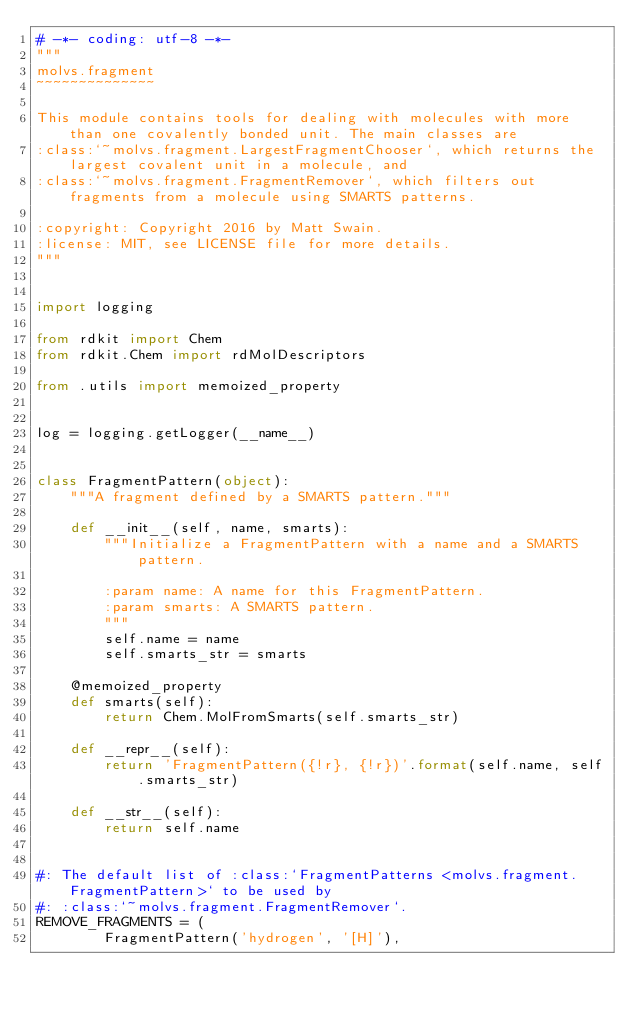Convert code to text. <code><loc_0><loc_0><loc_500><loc_500><_Python_># -*- coding: utf-8 -*-
"""
molvs.fragment
~~~~~~~~~~~~~~

This module contains tools for dealing with molecules with more than one covalently bonded unit. The main classes are
:class:`~molvs.fragment.LargestFragmentChooser`, which returns the largest covalent unit in a molecule, and
:class:`~molvs.fragment.FragmentRemover`, which filters out fragments from a molecule using SMARTS patterns.

:copyright: Copyright 2016 by Matt Swain.
:license: MIT, see LICENSE file for more details.
"""


import logging

from rdkit import Chem
from rdkit.Chem import rdMolDescriptors

from .utils import memoized_property


log = logging.getLogger(__name__)


class FragmentPattern(object):
    """A fragment defined by a SMARTS pattern."""

    def __init__(self, name, smarts):
        """Initialize a FragmentPattern with a name and a SMARTS pattern.

        :param name: A name for this FragmentPattern.
        :param smarts: A SMARTS pattern.
        """
        self.name = name
        self.smarts_str = smarts

    @memoized_property
    def smarts(self):
        return Chem.MolFromSmarts(self.smarts_str)

    def __repr__(self):
        return 'FragmentPattern({!r}, {!r})'.format(self.name, self.smarts_str)

    def __str__(self):
        return self.name


#: The default list of :class:`FragmentPatterns <molvs.fragment.FragmentPattern>` to be used by
#: :class:`~molvs.fragment.FragmentRemover`.
REMOVE_FRAGMENTS = (
        FragmentPattern('hydrogen', '[H]'),</code> 